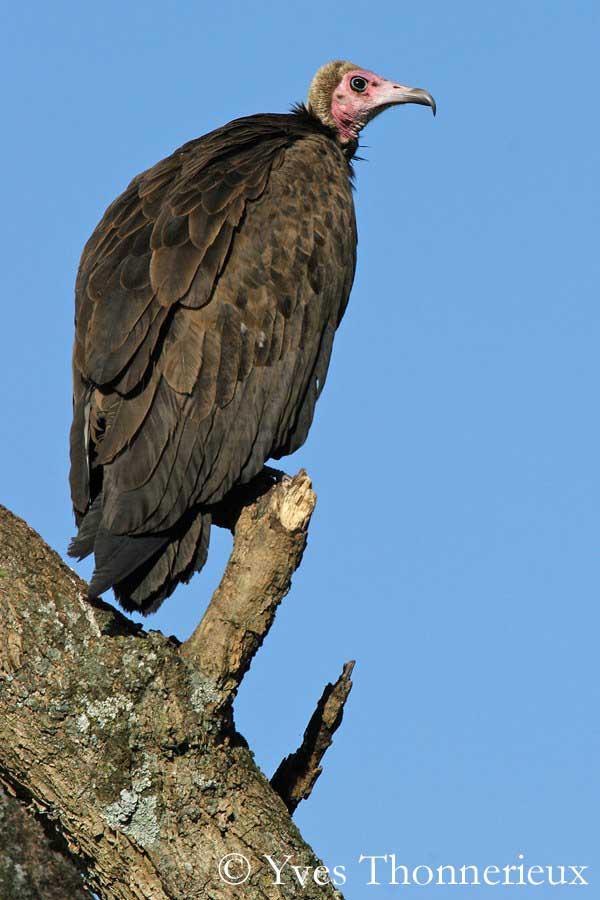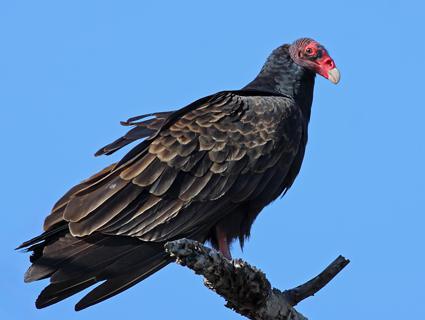The first image is the image on the left, the second image is the image on the right. For the images shown, is this caption "Two vultures are facing the opposite of each other." true? Answer yes or no. No. 